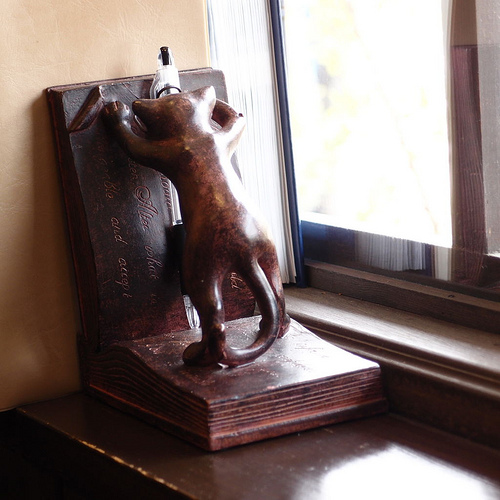<image>
Is the pen in front of the paperweight? Yes. The pen is positioned in front of the paperweight, appearing closer to the camera viewpoint. 